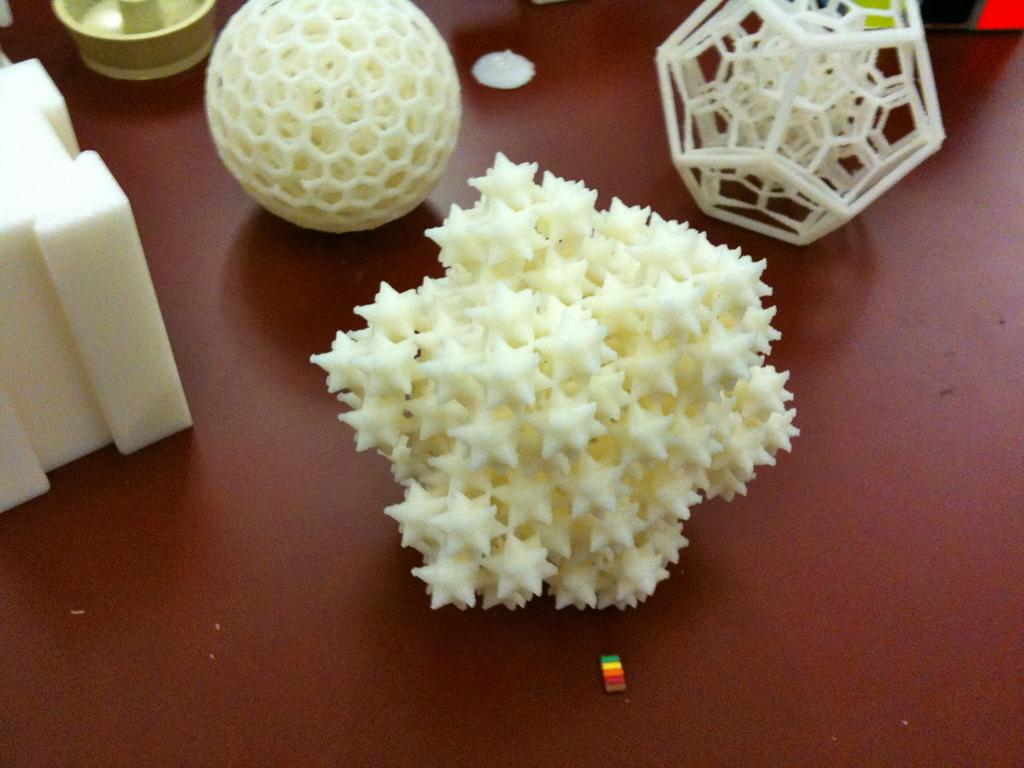What is the main object in the image? There is a ball in the image. Are there any other objects present in the image? Yes, there are other objects in the image. Where are the ball and objects located? The ball and objects are placed on a platform. What is the opinion of the ball in the image? The ball does not have an opinion, as it is an inanimate object. 